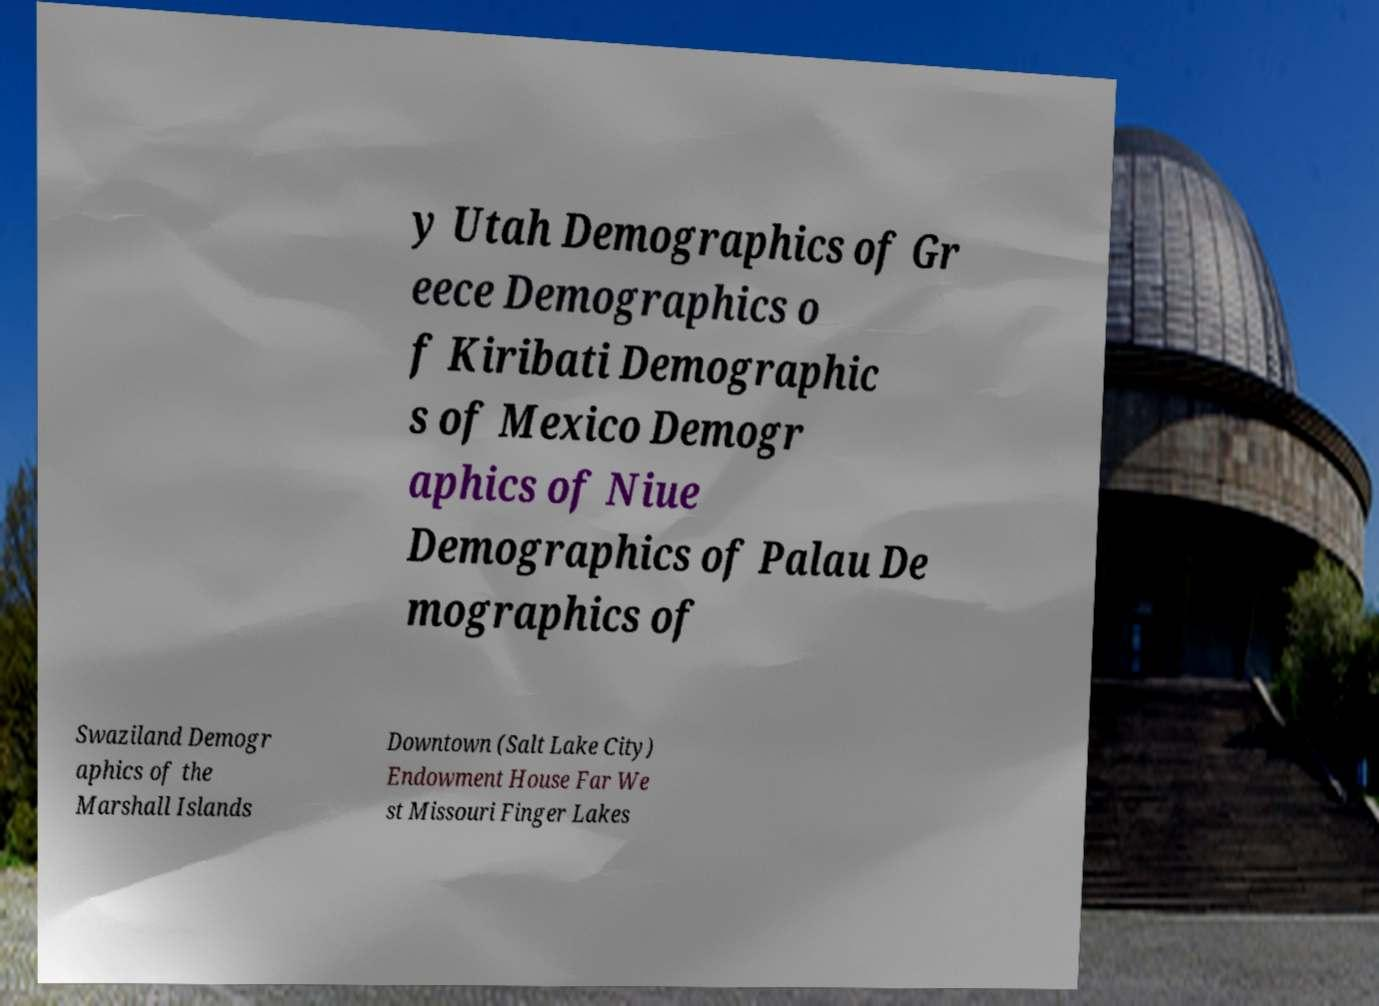Please identify and transcribe the text found in this image. y Utah Demographics of Gr eece Demographics o f Kiribati Demographic s of Mexico Demogr aphics of Niue Demographics of Palau De mographics of Swaziland Demogr aphics of the Marshall Islands Downtown (Salt Lake City) Endowment House Far We st Missouri Finger Lakes 